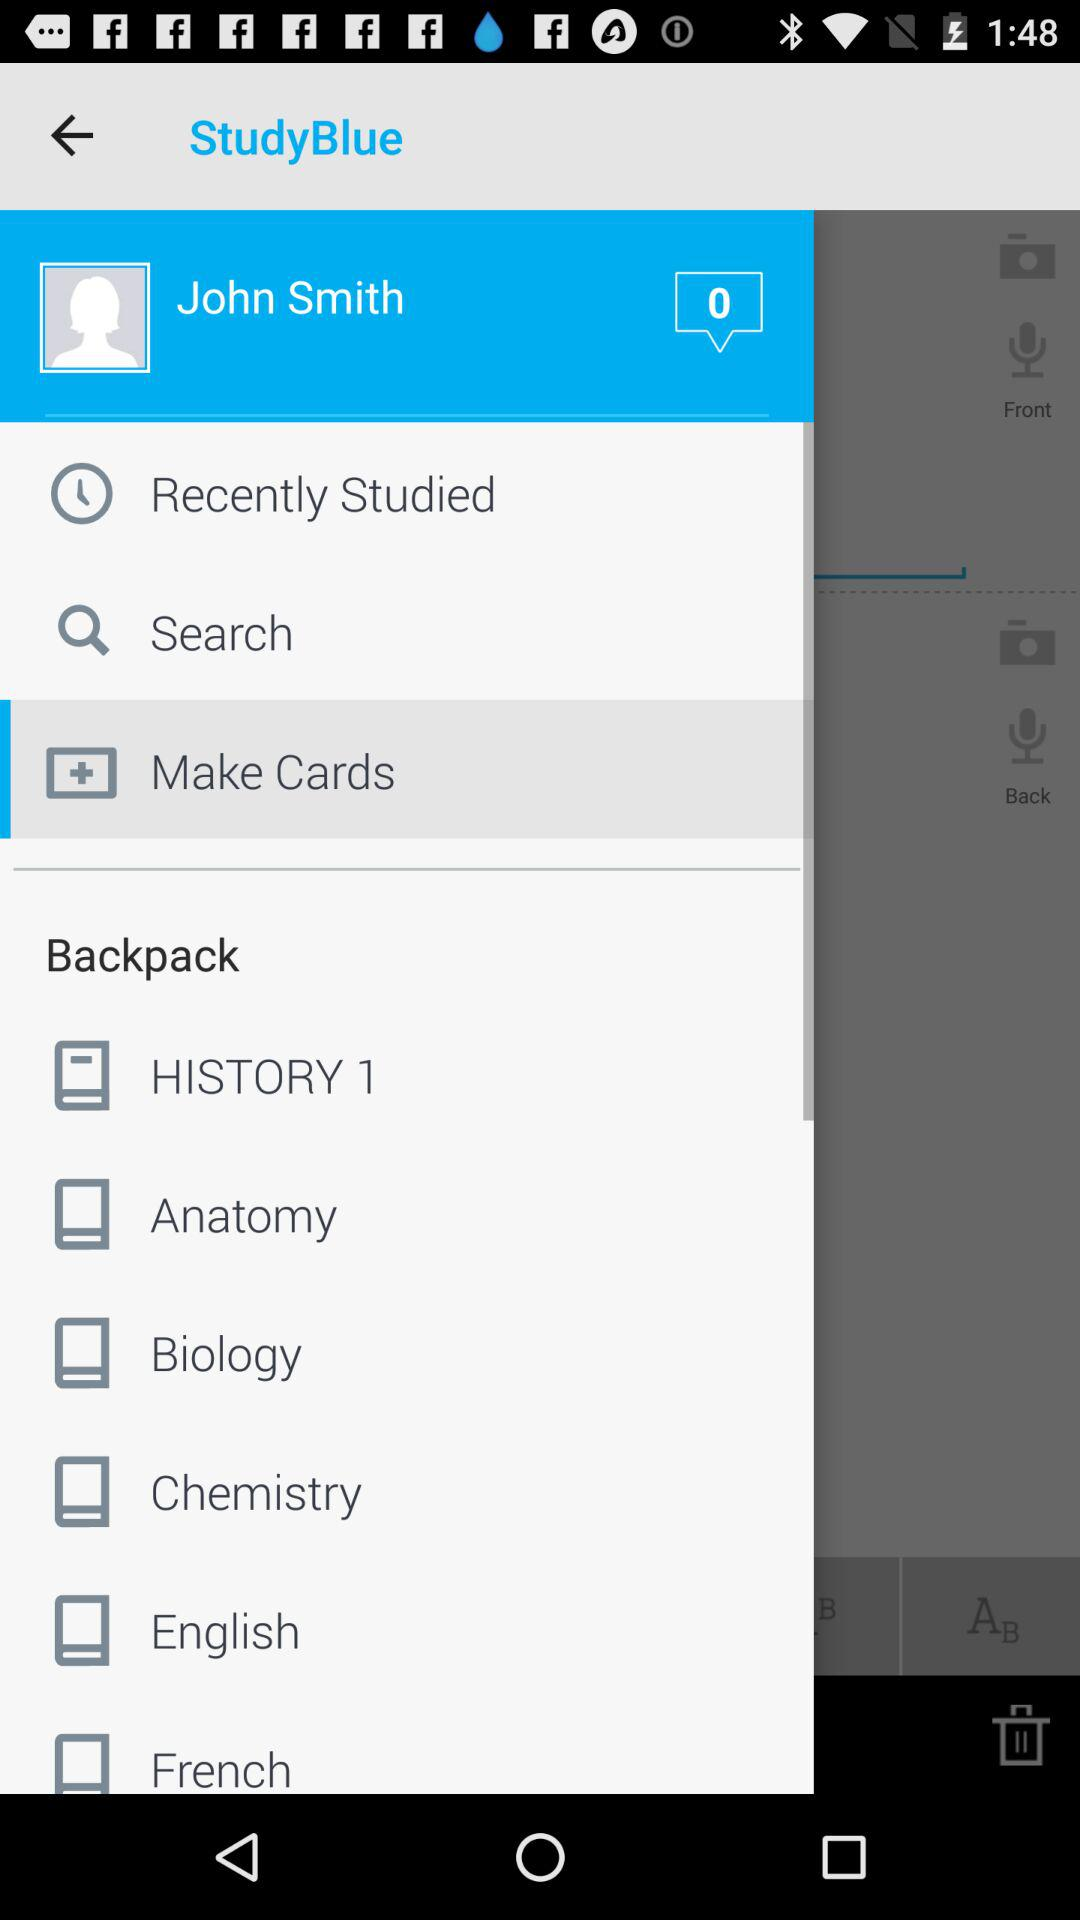What is the profile name? The profile name is John Smith. 